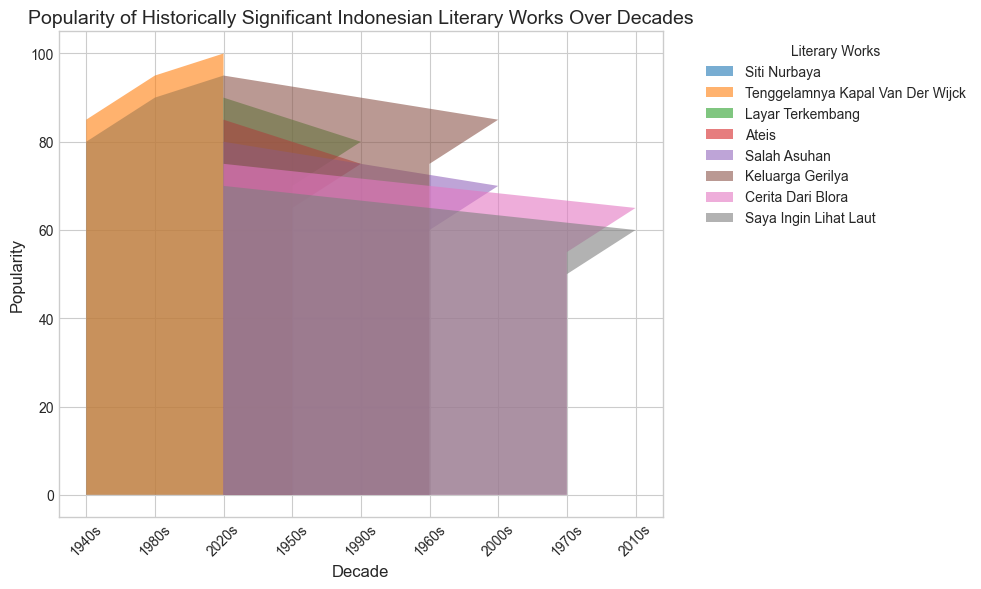Which literary work had the lowest popularity in the 1970s? The graph shows the popularity trends for each literary work across various decades. By examining the heights of the areas in the 1970s, "Saya Ingin Lihat Laut" had the lowest popularity, represented by the smallest area.
Answer: "Saya Ingin Lihat Laut" How did the popularity of "Siti Nurbaya" change from the 1940s to the 2020s? To track the changes in "Siti Nurbaya's" popularity, observe its area height or level in each decade. It started from 80 in the 1940s and increased up to 95 in the 2020s.
Answer: Increased from 80 to 95 In which decade did "Tenggelamnya Kapal Van Der Wijck" gain its highest popularity? By checking the peaks of the area designated for "Tenggelamnya Kapal Van Der Wijck" in each decade, the highest popularity can be seen in the 2020s where it reaches 100.
Answer: 2020s Compare the popularity of "Layar Terkembang" in the 1950s and the 1990s. Which decade had higher popularity and by how much? By comparing the heights for "Layar Terkembang" in the 1950s and 1990s, it was 70 in the 1950s and 80 in the 1990s. The 1990s had higher popularity by 10 units.
Answer: 1990s by 10 units What can you infer about the trend of "Ateis" from the 1950s to the 2020s? Examine the changes in the area representing "Ateis." It had varying values, starting at 65 in the 1950s and reaching up to 85 in the 2020s, showing an overall increasing trend.
Answer: Overall increasing trend Which literary work showed a resurgence in popularity in the 2020s after a drop in previous decades? Identifying the works with fluctuating trends, "Salah Asuhan" showed a notable resurgence in the 2020s, increasing to 80 after a drop in previous decades.
Answer: "Salah Asuhan" Calculate the average popularity of "Keluarga Gerilya" over all recorded decades. Sum the popularity values for "Keluarga Gerilya" across all decades: 75 (1960s) + 85 (2000s) + 95 (2020s) = 255. Then divide by the number of decades, which is 3: 255/3 = 85.
Answer: 85 Which literary works maintained a consistent upward trend in popularity from their first recorded decade to the 2020s? By examining the popularity progression lines of each work, "Siti Nurbaya" and "Tenggelamnya Kapal Van Der Wijck" both show a consistent upward trend from their initial recordings to the 2020s.
Answer: "Siti Nurbaya" and "Tenggelamnya Kapal Van Der Wijck" What was the difference in popularity between "Cerita Dari Blora" in the 1970s and 2010s? Comparing the heights representing the popularity of “Cerita Dari Blora”, it was 55 in the 1970s and 65 in the 2010s. The difference is 65 - 55 = 10.
Answer: 10 